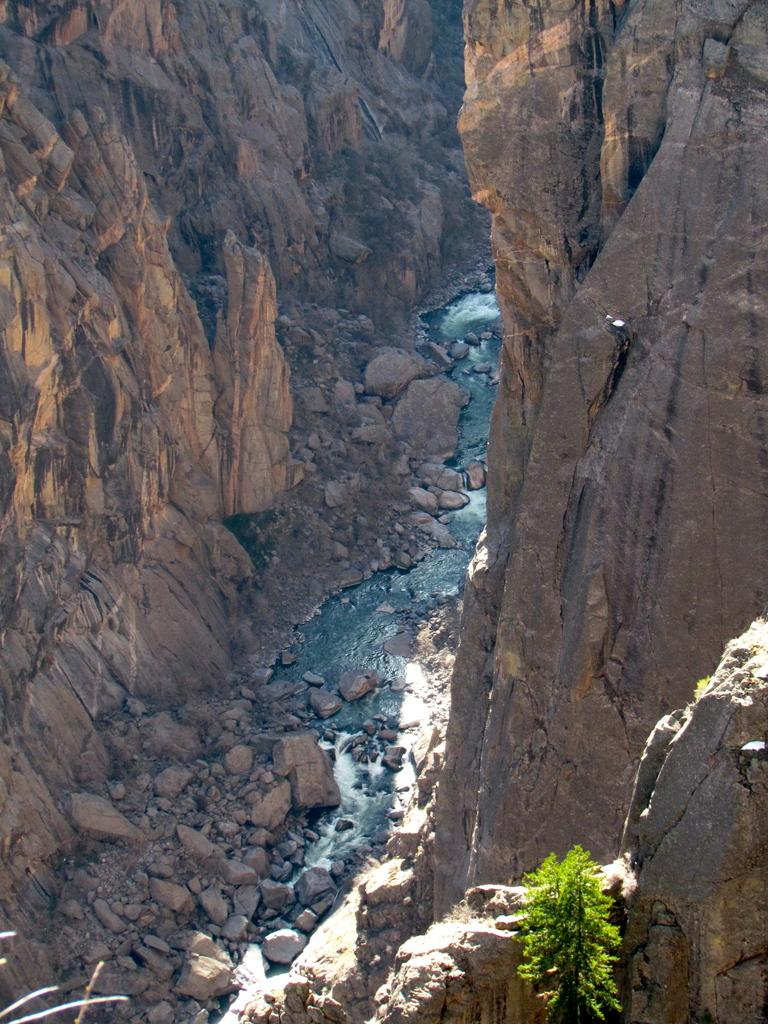What is the main feature of the image? There is a water stream in the image. What type of natural formation can be seen in the background? There are mountains in the image. What type of vegetation is present at the bottom of the image? There is a plant at the bottom of the image. Can you see any flights taking off or landing in the image? There is no reference to any flights or airplanes in the image. Is there a notebook visible in the image? There is no notebook present in the image. 